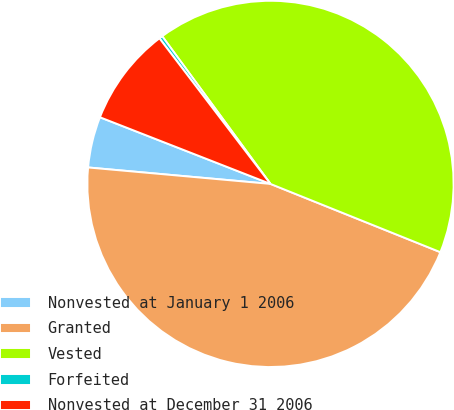<chart> <loc_0><loc_0><loc_500><loc_500><pie_chart><fcel>Nonvested at January 1 2006<fcel>Granted<fcel>Vested<fcel>Forfeited<fcel>Nonvested at December 31 2006<nl><fcel>4.5%<fcel>45.35%<fcel>41.15%<fcel>0.3%<fcel>8.7%<nl></chart> 